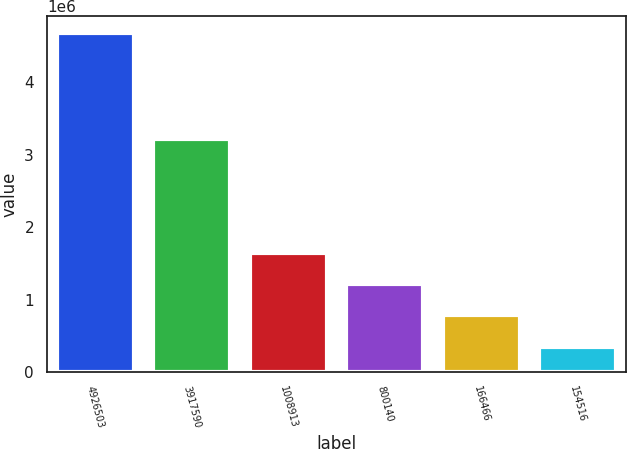Convert chart. <chart><loc_0><loc_0><loc_500><loc_500><bar_chart><fcel>4926503<fcel>3917590<fcel>1008913<fcel>800140<fcel>166466<fcel>154516<nl><fcel>4.68368e+06<fcel>3.22357e+06<fcel>1.64697e+06<fcel>1.21315e+06<fcel>779333<fcel>345516<nl></chart> 